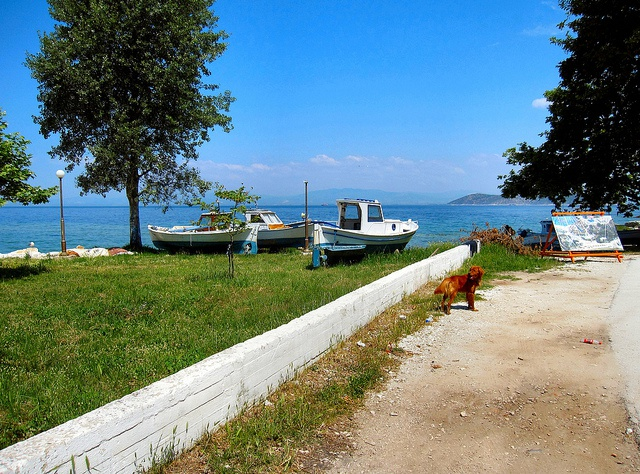Describe the objects in this image and their specific colors. I can see boat in gray, black, lightgray, and darkgreen tones, boat in gray, white, black, teal, and blue tones, and dog in gray, maroon, brown, and black tones in this image. 